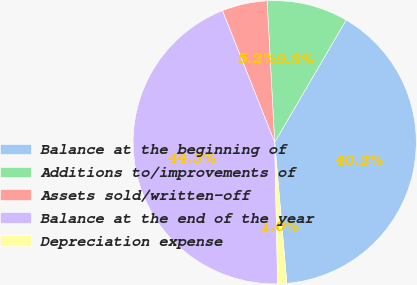<chart> <loc_0><loc_0><loc_500><loc_500><pie_chart><fcel>Balance at the beginning of<fcel>Additions to/improvements of<fcel>Assets sold/written-off<fcel>Balance at the end of the year<fcel>Depreciation expense<nl><fcel>40.21%<fcel>9.27%<fcel>5.16%<fcel>44.32%<fcel>1.04%<nl></chart> 